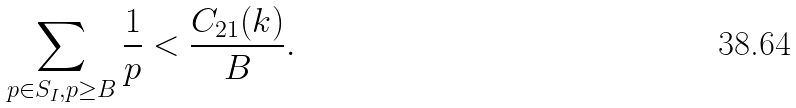Convert formula to latex. <formula><loc_0><loc_0><loc_500><loc_500>\sum _ { p \in S _ { I } , p \geq B } \frac { 1 } { p } < \frac { C _ { 2 1 } ( k ) } { B } .</formula> 